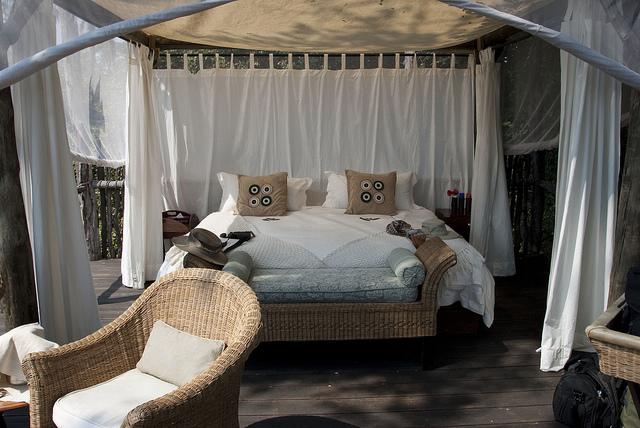How many pillows are on the bed?
Give a very brief answer. 4. What type of patterns do the pillows have?
Concise answer only. Circles. Is there a cushion on the chair?
Answer briefly. Yes. 